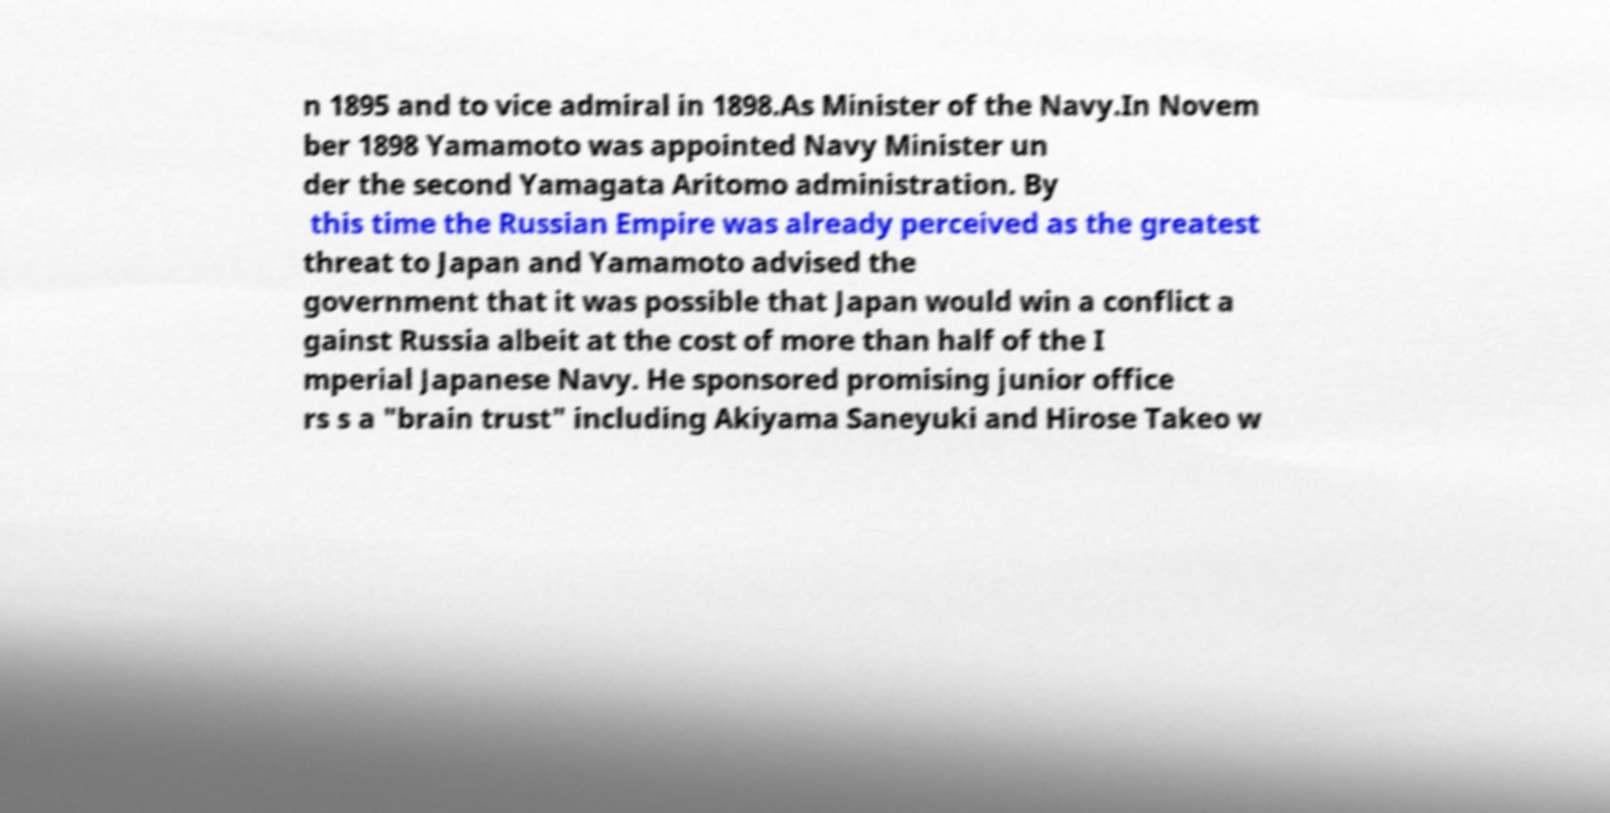Could you extract and type out the text from this image? n 1895 and to vice admiral in 1898.As Minister of the Navy.In Novem ber 1898 Yamamoto was appointed Navy Minister un der the second Yamagata Aritomo administration. By this time the Russian Empire was already perceived as the greatest threat to Japan and Yamamoto advised the government that it was possible that Japan would win a conflict a gainst Russia albeit at the cost of more than half of the I mperial Japanese Navy. He sponsored promising junior office rs s a "brain trust" including Akiyama Saneyuki and Hirose Takeo w 